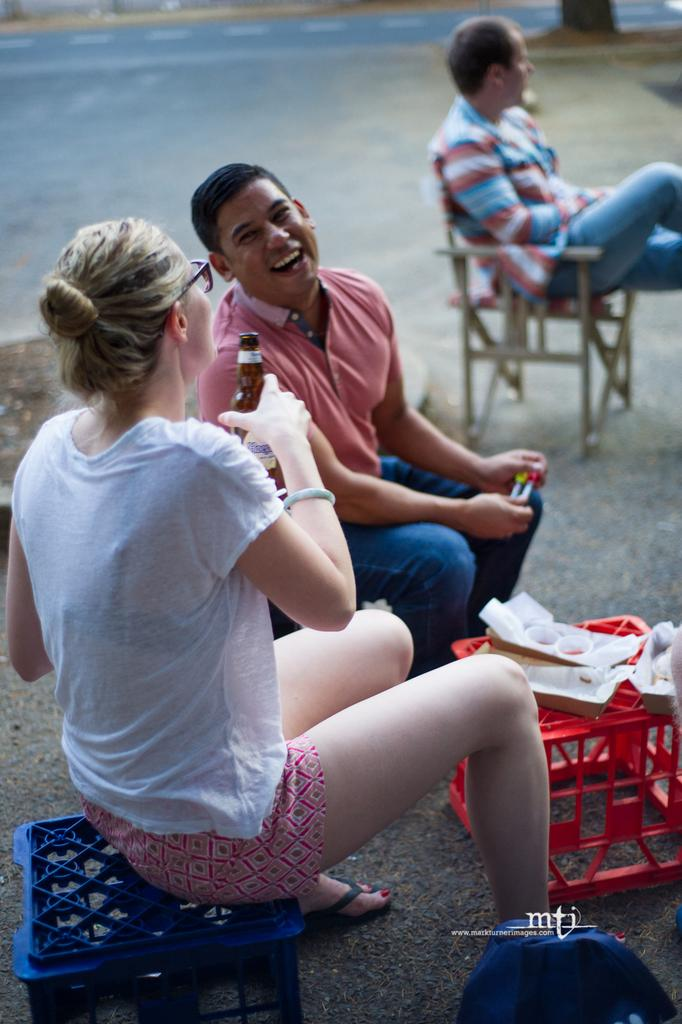How many people are in the image? There are three persons in the image. What are two of the persons doing with their hands? Two of the persons are holding an object in their hands. What type of guitar is the father playing in the image? There is no guitar or father present in the image. What type of business are the persons discussing in the image? There is no indication of a business discussion in the image. 